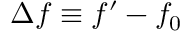Convert formula to latex. <formula><loc_0><loc_0><loc_500><loc_500>f \equiv f ^ { \prime } - f _ { 0 }</formula> 